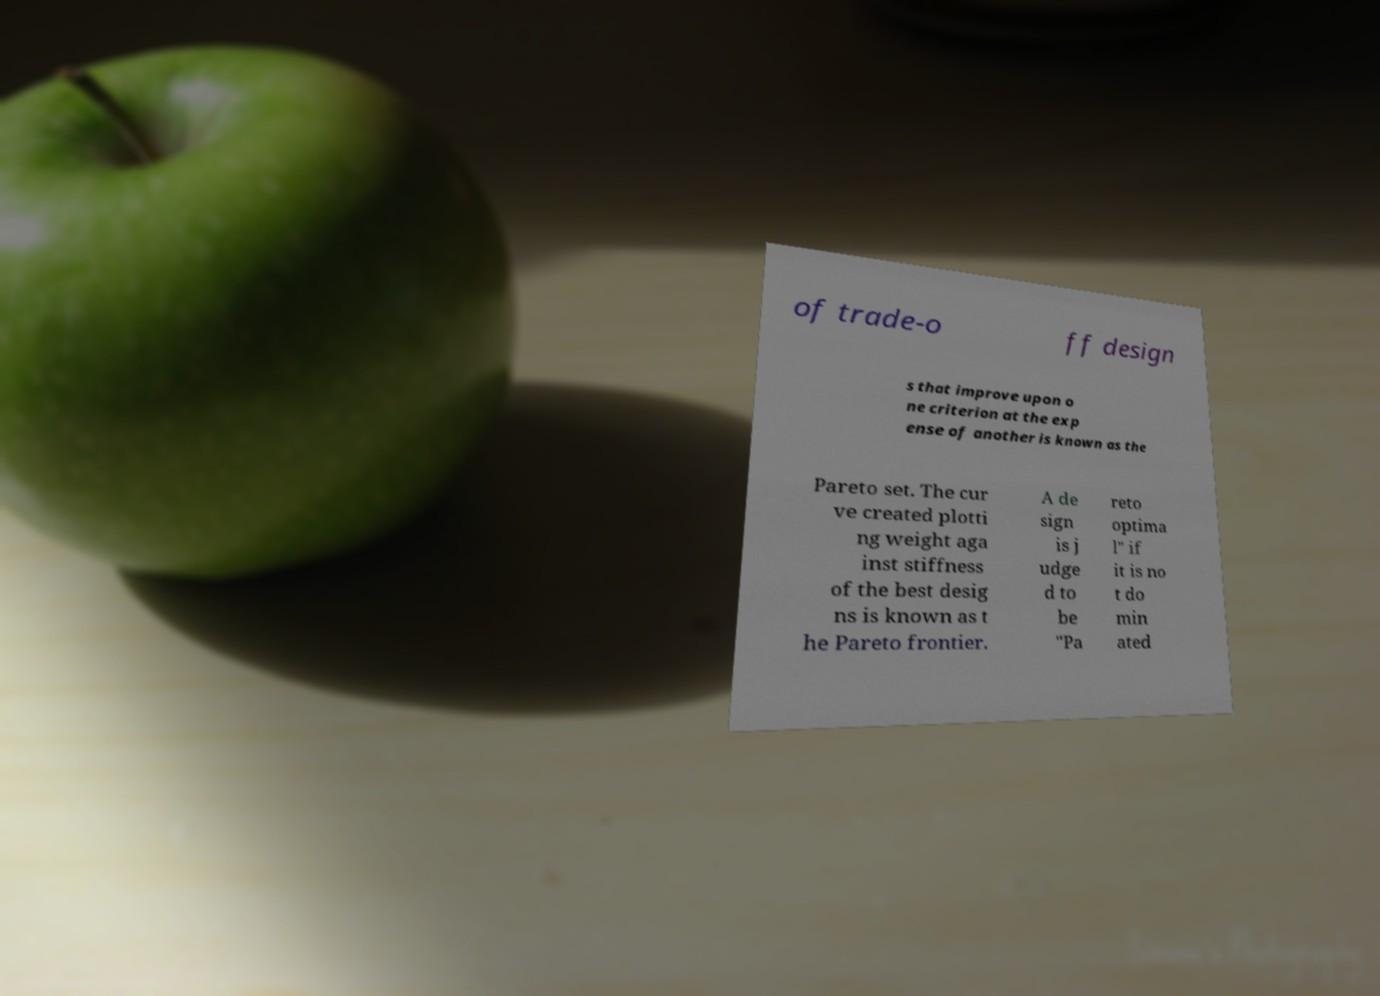Could you assist in decoding the text presented in this image and type it out clearly? of trade-o ff design s that improve upon o ne criterion at the exp ense of another is known as the Pareto set. The cur ve created plotti ng weight aga inst stiffness of the best desig ns is known as t he Pareto frontier. A de sign is j udge d to be "Pa reto optima l" if it is no t do min ated 